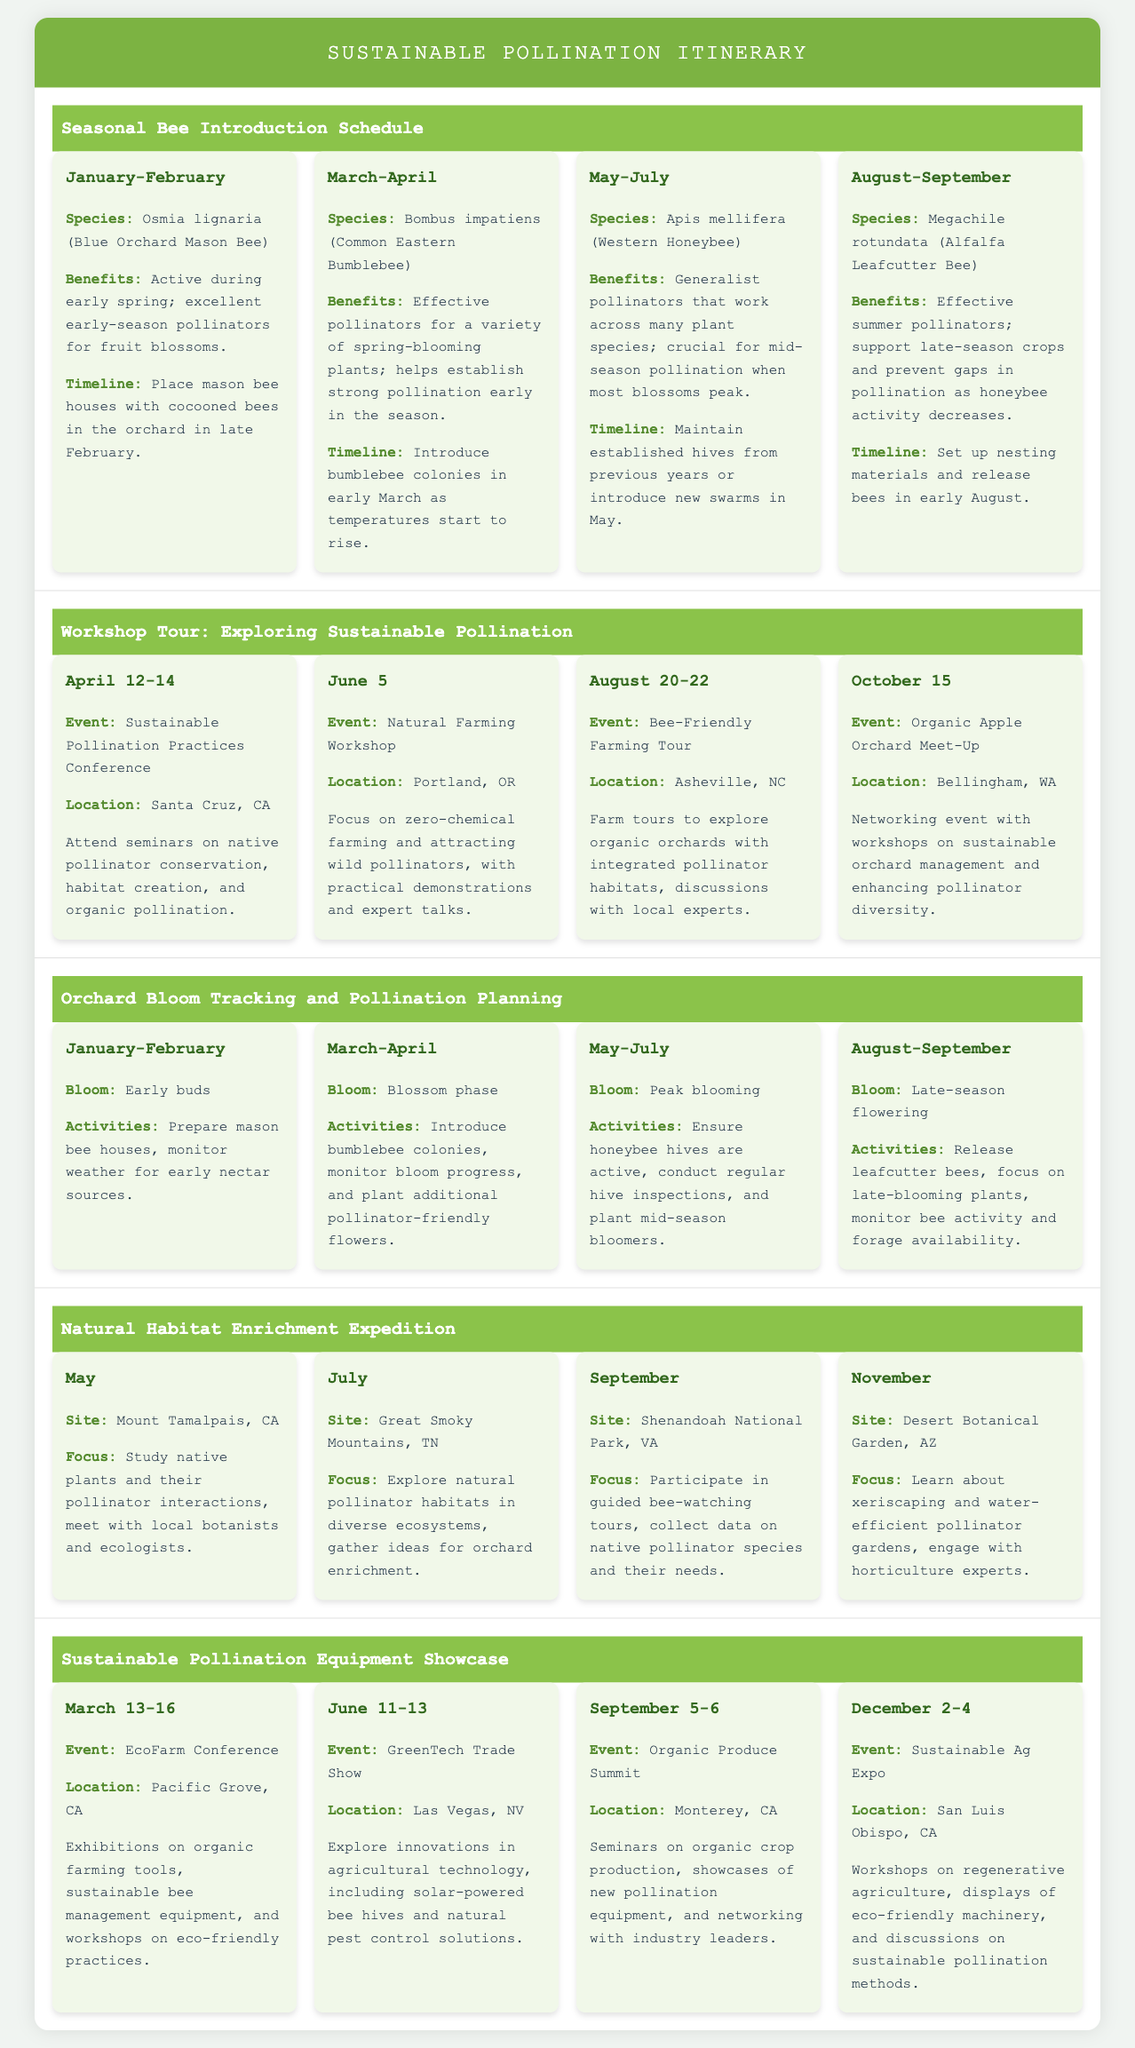What is the species introduced in March-April? The species introduced during this period is Bombus impatiens (Common Eastern Bumblebee), as outlined in the itinerary.
Answer: Bombus impatiens (Common Eastern Bumblebee) What is the location of the Sustainable Pollination Practices Conference? The location is detailed in the workshop tour section, specifically for the event occurring from April 12-14.
Answer: Santa Cruz, CA What is the focus of the expedition in November? The focus for the November expedition is to learn about xeriscaping and water-efficient pollinator gardens.
Answer: Learn about xeriscaping and water-efficient pollinator gardens How many bee species are introduced throughout the year? The document outlines the introduction of four different bee species, each scheduled for specific time periods.
Answer: Four What activities are recommended during May-July bloom periods? The itinerary suggests ensuring honeybee hives are active, conducting regular hive inspections, and planting mid-season bloomers during this period.
Answer: Ensure honeybee hives are active, conduct regular hive inspections, plant mid-season bloomers What is occurring on June 11-13? The document describes an event happening on those dates, focusing on exploring innovations in agricultural technology at the GreenTech Trade Show.
Answer: GreenTech Trade Show What type of workshops are mentioned for October 15? The workshops are on sustainable orchard management and enhancing pollinator diversity during the Organic Apple Orchard Meet-Up.
Answer: Sustainable orchard management and enhancing pollinator diversity Which bee species is introduced in the late summer (August-September)? The species introduced during this time period is Megachile rotundata (Alfalfa Leafcutter Bee).
Answer: Megachile rotundata (Alfalfa Leafcutter Bee) How many parts are in the Sustainable Pollination Itinerary? The itinerary comprises five distinct sections focusing on various aspects of pollination and bee introduction.
Answer: Five 